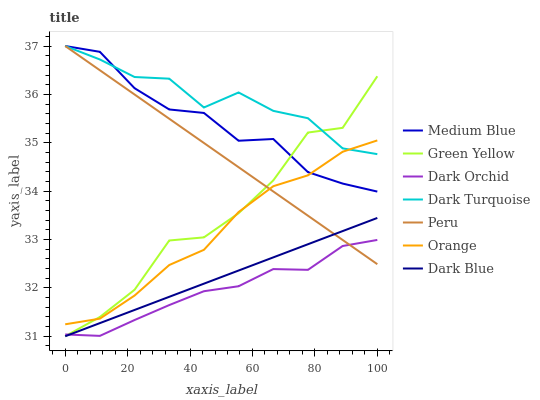Does Dark Orchid have the minimum area under the curve?
Answer yes or no. Yes. Does Dark Turquoise have the maximum area under the curve?
Answer yes or no. Yes. Does Medium Blue have the minimum area under the curve?
Answer yes or no. No. Does Medium Blue have the maximum area under the curve?
Answer yes or no. No. Is Peru the smoothest?
Answer yes or no. Yes. Is Green Yellow the roughest?
Answer yes or no. Yes. Is Medium Blue the smoothest?
Answer yes or no. No. Is Medium Blue the roughest?
Answer yes or no. No. Does Dark Blue have the lowest value?
Answer yes or no. Yes. Does Medium Blue have the lowest value?
Answer yes or no. No. Does Peru have the highest value?
Answer yes or no. Yes. Does Dark Orchid have the highest value?
Answer yes or no. No. Is Dark Orchid less than Orange?
Answer yes or no. Yes. Is Orange greater than Dark Blue?
Answer yes or no. Yes. Does Dark Turquoise intersect Orange?
Answer yes or no. Yes. Is Dark Turquoise less than Orange?
Answer yes or no. No. Is Dark Turquoise greater than Orange?
Answer yes or no. No. Does Dark Orchid intersect Orange?
Answer yes or no. No. 